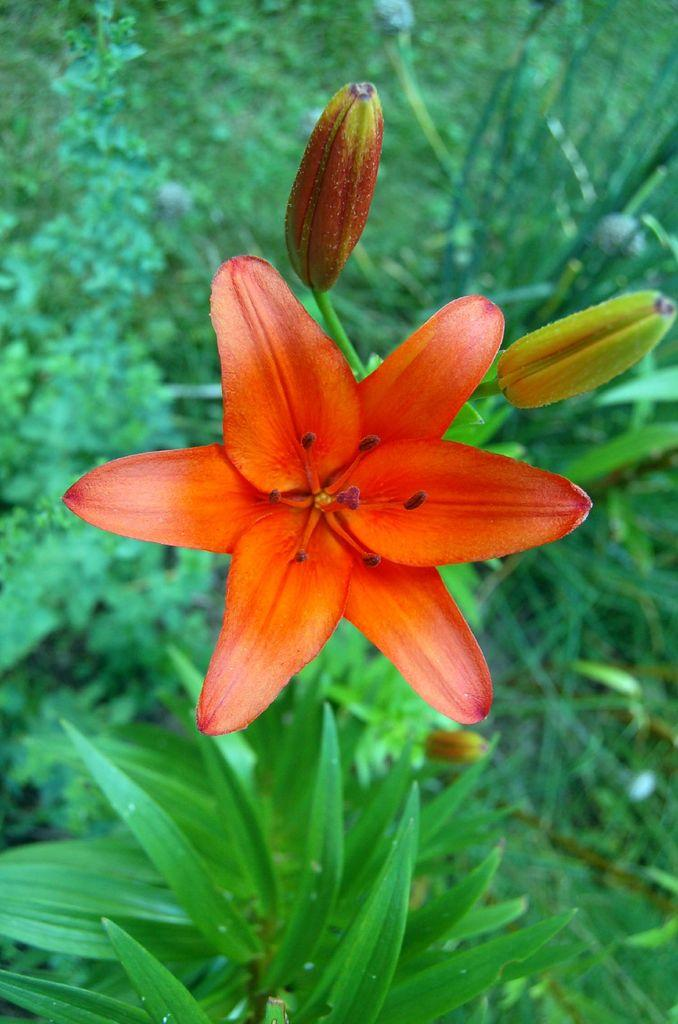What type of flower can be seen on the plant in the image? There is an orange flower on a plant in the image. What can be found on the plant besides the flower? There are seeds visible on the plant. What is visible in the background of the image? There is a group of plants in the background of the image. Where is the mine located in the image? There is no mine present in the image. What type of field can be seen in the image? There is no field present in the image. 